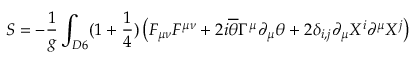Convert formula to latex. <formula><loc_0><loc_0><loc_500><loc_500>S = - \frac { 1 } { g } \int _ { D 6 } ( 1 + \frac { 1 } { 4 } ) \left ( F _ { \mu \nu } F ^ { \mu \nu } + 2 i \overline { \theta } \Gamma ^ { \mu } \partial _ { \mu } \theta + 2 \delta _ { i , j } \partial _ { \mu } X ^ { i } \partial ^ { \mu } X ^ { j } \right )</formula> 